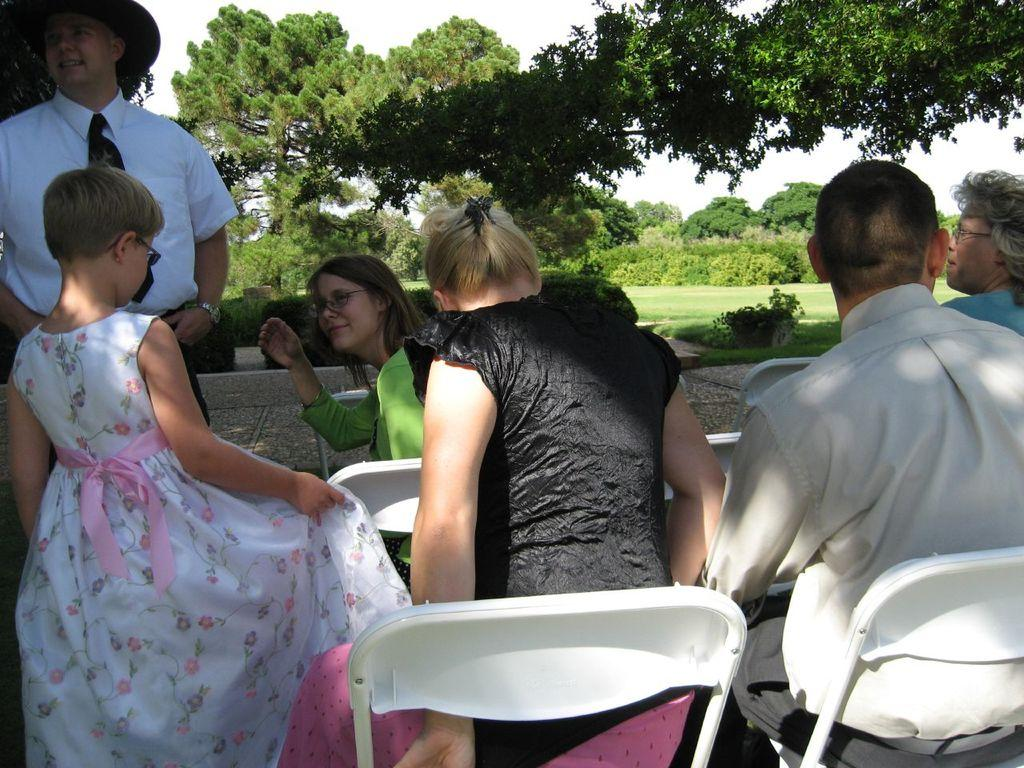How many people are sitting in chairs in the image? There are four people sitting in chairs in the image. Are there any other people besides the ones sitting in chairs? Yes, a man and a girl are standing beside the sitting people. What can be seen in the background of the image? There are trees in the background of the image. How many birds are in the flock flying over the people in the image? There is no flock of birds visible in the image; only people and trees are present. 